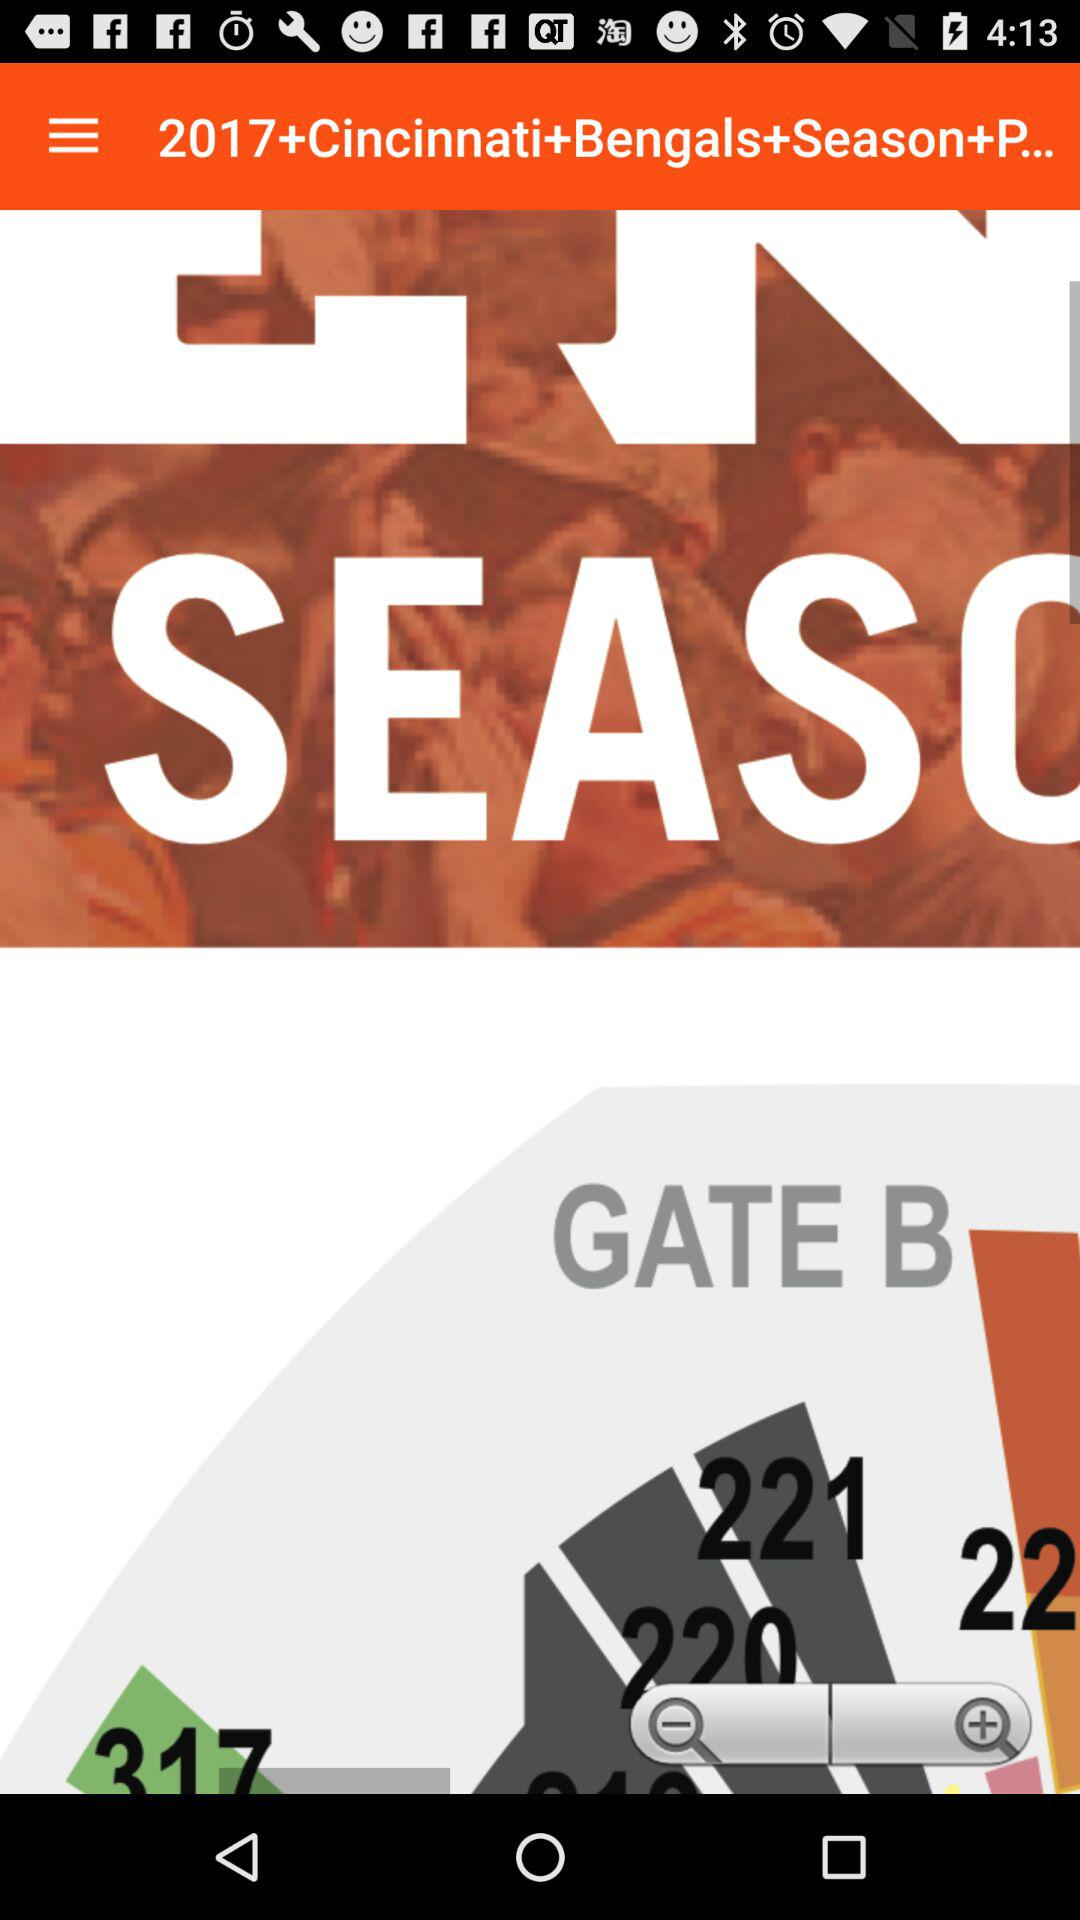How many magnifying glasses are there on the screen?
Answer the question using a single word or phrase. 2 